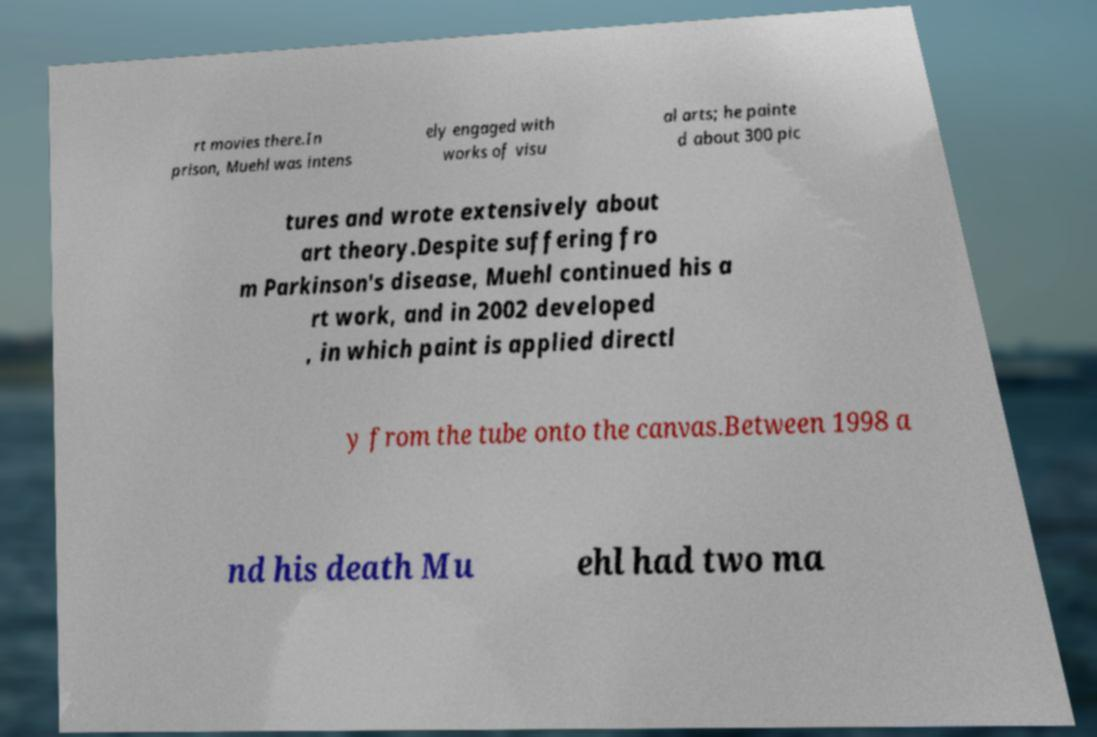What messages or text are displayed in this image? I need them in a readable, typed format. rt movies there.In prison, Muehl was intens ely engaged with works of visu al arts; he painte d about 300 pic tures and wrote extensively about art theory.Despite suffering fro m Parkinson's disease, Muehl continued his a rt work, and in 2002 developed , in which paint is applied directl y from the tube onto the canvas.Between 1998 a nd his death Mu ehl had two ma 